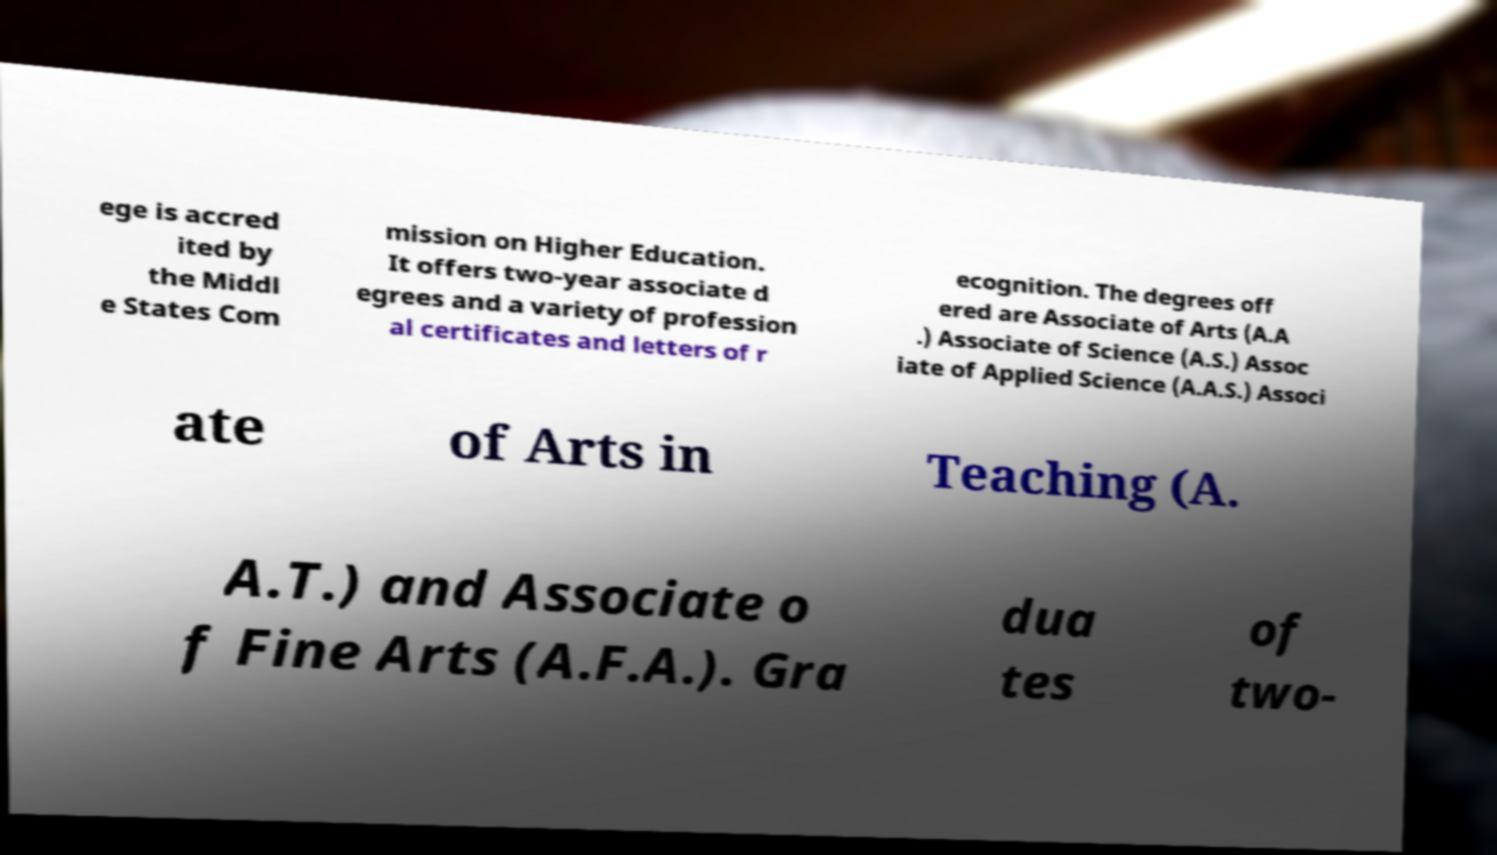Can you accurately transcribe the text from the provided image for me? ege is accred ited by the Middl e States Com mission on Higher Education. It offers two-year associate d egrees and a variety of profession al certificates and letters of r ecognition. The degrees off ered are Associate of Arts (A.A .) Associate of Science (A.S.) Assoc iate of Applied Science (A.A.S.) Associ ate of Arts in Teaching (A. A.T.) and Associate o f Fine Arts (A.F.A.). Gra dua tes of two- 